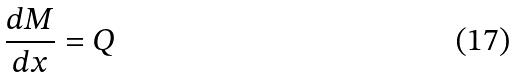Convert formula to latex. <formula><loc_0><loc_0><loc_500><loc_500>\frac { d M } { d x } = Q</formula> 